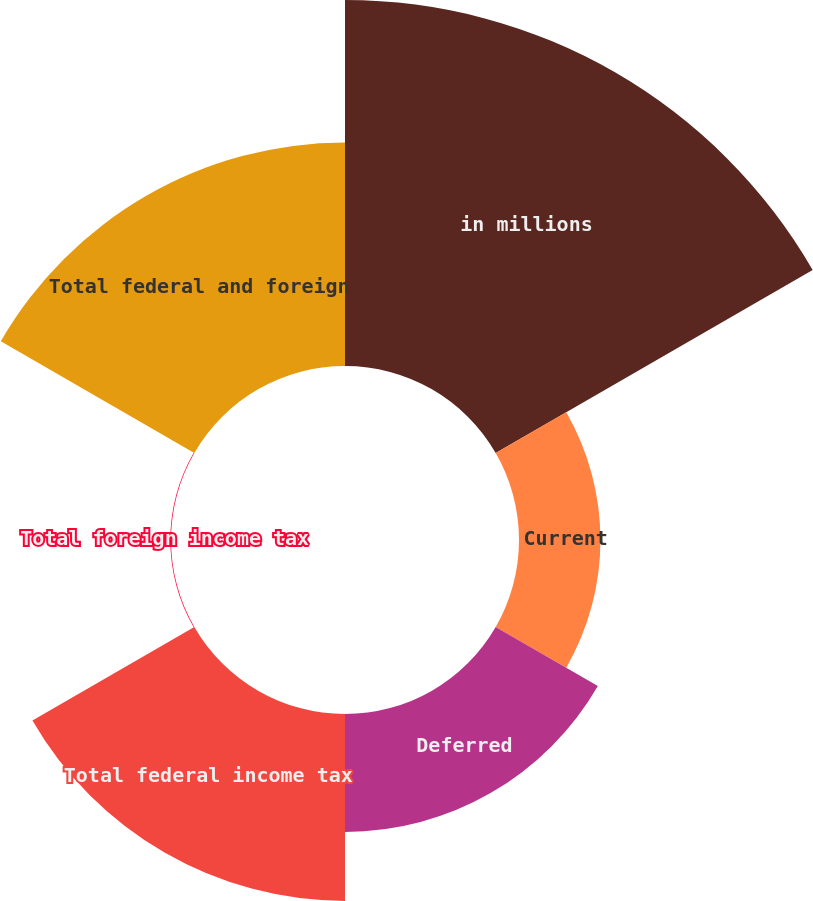Convert chart to OTSL. <chart><loc_0><loc_0><loc_500><loc_500><pie_chart><fcel>in millions<fcel>Current<fcel>Deferred<fcel>Total federal income tax<fcel>Total foreign income tax<fcel>Total federal and foreign<nl><fcel>37.48%<fcel>8.34%<fcel>12.08%<fcel>19.14%<fcel>0.07%<fcel>22.88%<nl></chart> 